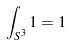Convert formula to latex. <formula><loc_0><loc_0><loc_500><loc_500>\int _ { S ^ { 3 } } 1 = 1</formula> 